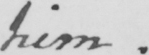What is written in this line of handwriting? him. 